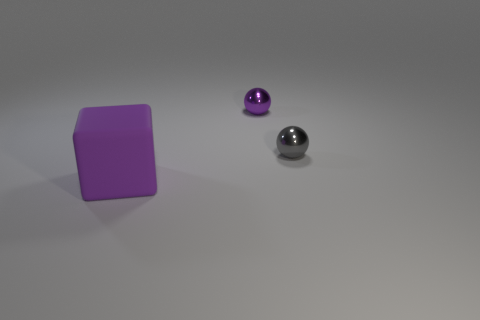Add 1 small purple metal blocks. How many objects exist? 4 Subtract all spheres. How many objects are left? 1 Subtract 0 red balls. How many objects are left? 3 Subtract all big yellow matte cylinders. Subtract all small gray balls. How many objects are left? 2 Add 3 gray spheres. How many gray spheres are left? 4 Add 3 purple rubber blocks. How many purple rubber blocks exist? 4 